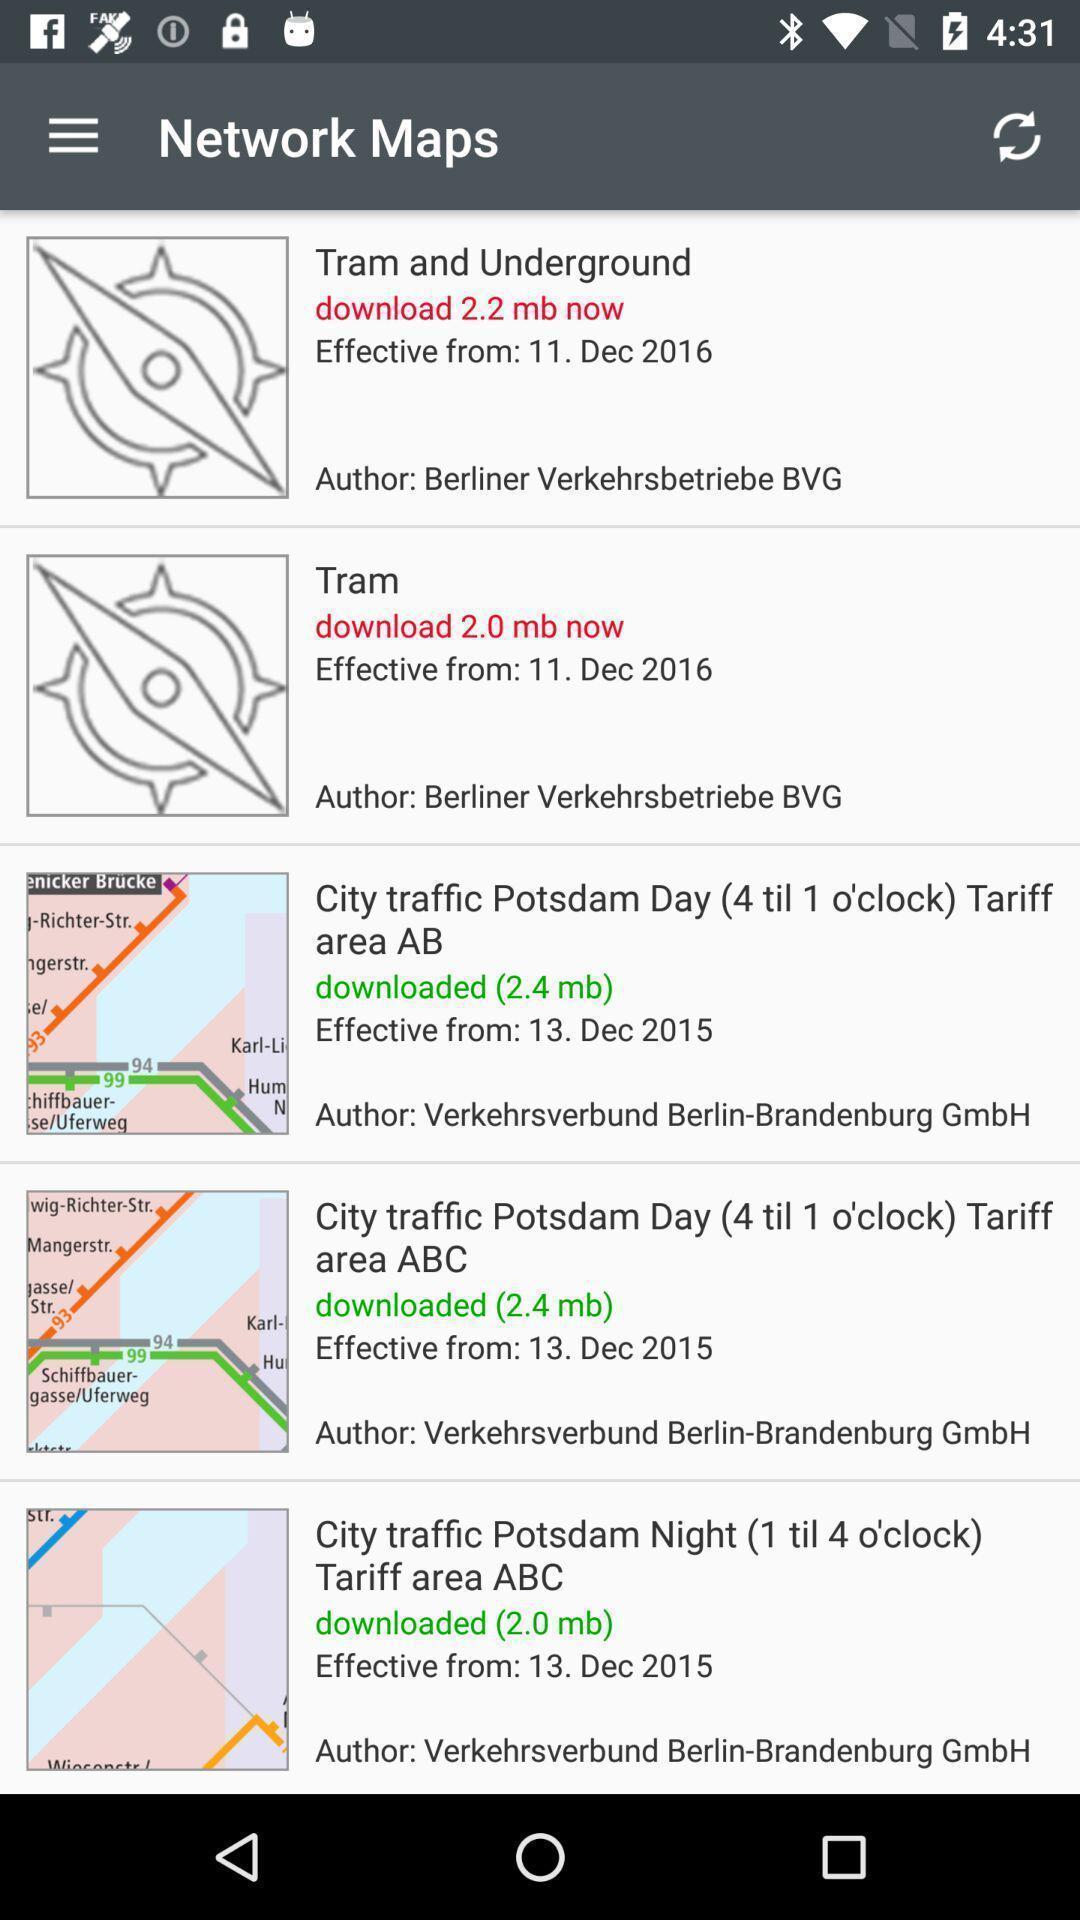Give me a narrative description of this picture. Various maps list page displayed of a navigation app. 